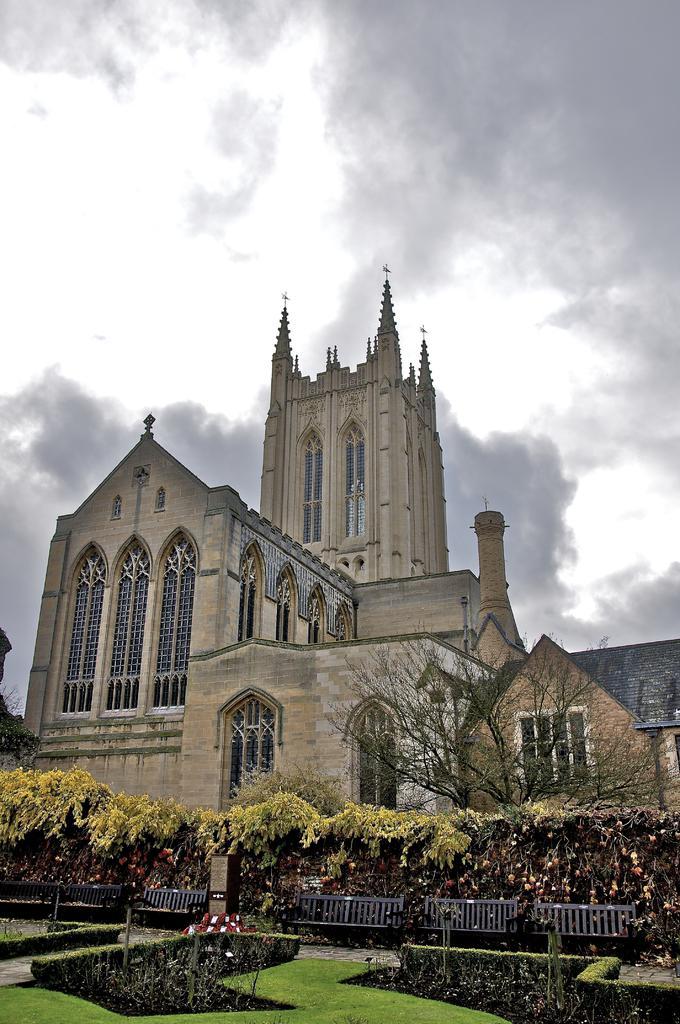Can you describe this image briefly? There are plants and grass on the ground. In the background, there are buildings having windows and roofs and there are clouds in the sky. 